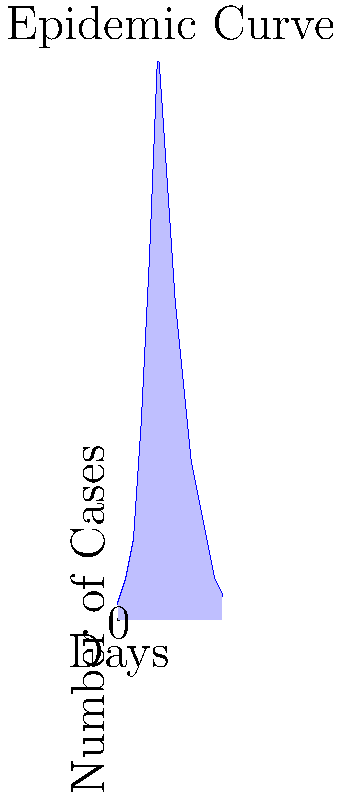As a humanitarian worker in central Africa, you're monitoring a disease outbreak. The epidemic curve graph shows the number of new cases per day. What is the approximate duration of the outbreak based on this curve? To determine the duration of the outbreak, we need to analyze the epidemic curve graph:

1. Identify the start of the outbreak:
   The graph begins with the first reported cases on day 0.

2. Identify the end of the outbreak:
   The last day with reported cases is at the end of the x-axis, which is day 13.

3. Calculate the duration:
   The outbreak duration is the time between the first and last reported cases.
   Duration = Last day with cases - First day with cases
   Duration = 13 - 0 = 13 days

4. Add one day to include both the start and end dates:
   Total duration = 13 + 1 = 14 days

Therefore, the approximate duration of the outbreak based on this epidemic curve is 14 days.
Answer: 14 days 